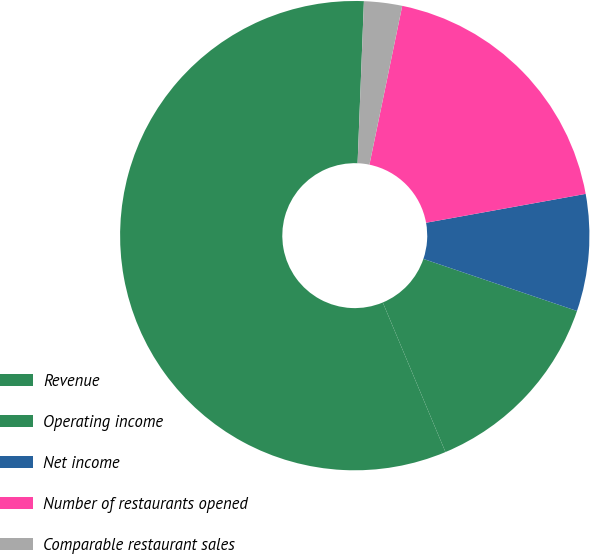Convert chart to OTSL. <chart><loc_0><loc_0><loc_500><loc_500><pie_chart><fcel>Revenue<fcel>Operating income<fcel>Net income<fcel>Number of restaurants opened<fcel>Comparable restaurant sales<nl><fcel>56.94%<fcel>13.48%<fcel>8.05%<fcel>18.91%<fcel>2.62%<nl></chart> 